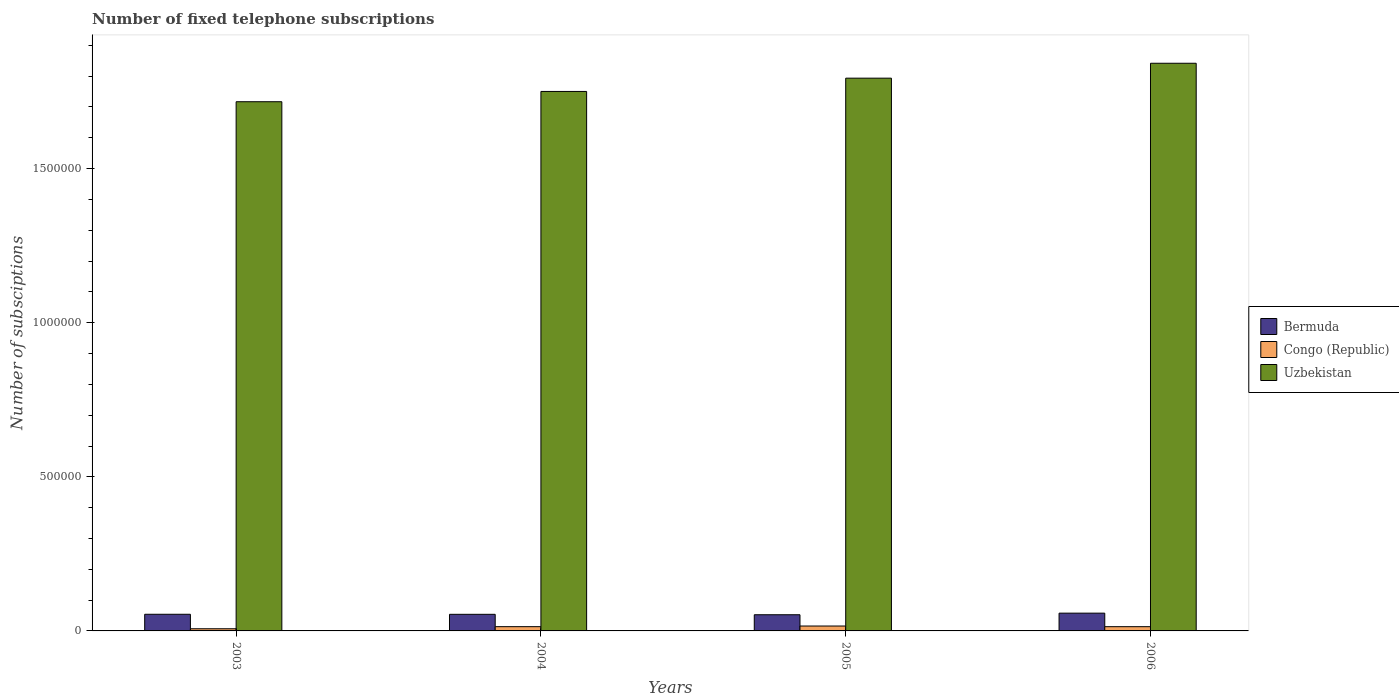How many groups of bars are there?
Provide a short and direct response. 4. Are the number of bars per tick equal to the number of legend labels?
Provide a short and direct response. Yes. Are the number of bars on each tick of the X-axis equal?
Offer a terse response. Yes. How many bars are there on the 1st tick from the left?
Give a very brief answer. 3. In how many cases, is the number of bars for a given year not equal to the number of legend labels?
Offer a very short reply. 0. What is the number of fixed telephone subscriptions in Bermuda in 2004?
Give a very brief answer. 5.38e+04. Across all years, what is the maximum number of fixed telephone subscriptions in Congo (Republic)?
Your answer should be very brief. 1.59e+04. Across all years, what is the minimum number of fixed telephone subscriptions in Uzbekistan?
Keep it short and to the point. 1.72e+06. In which year was the number of fixed telephone subscriptions in Uzbekistan minimum?
Make the answer very short. 2003. What is the total number of fixed telephone subscriptions in Bermuda in the graph?
Give a very brief answer. 2.18e+05. What is the difference between the number of fixed telephone subscriptions in Congo (Republic) in 2003 and that in 2004?
Provide a succinct answer. -6820. What is the difference between the number of fixed telephone subscriptions in Uzbekistan in 2005 and the number of fixed telephone subscriptions in Congo (Republic) in 2004?
Ensure brevity in your answer.  1.78e+06. What is the average number of fixed telephone subscriptions in Congo (Republic) per year?
Offer a terse response. 1.26e+04. In the year 2004, what is the difference between the number of fixed telephone subscriptions in Bermuda and number of fixed telephone subscriptions in Congo (Republic)?
Your answer should be very brief. 4.00e+04. What is the ratio of the number of fixed telephone subscriptions in Bermuda in 2003 to that in 2005?
Your response must be concise. 1.03. Is the difference between the number of fixed telephone subscriptions in Bermuda in 2003 and 2004 greater than the difference between the number of fixed telephone subscriptions in Congo (Republic) in 2003 and 2004?
Provide a succinct answer. Yes. What is the difference between the highest and the second highest number of fixed telephone subscriptions in Bermuda?
Provide a succinct answer. 3654. What is the difference between the highest and the lowest number of fixed telephone subscriptions in Uzbekistan?
Your answer should be compact. 1.25e+05. What does the 3rd bar from the left in 2006 represents?
Provide a succinct answer. Uzbekistan. What does the 3rd bar from the right in 2004 represents?
Give a very brief answer. Bermuda. Is it the case that in every year, the sum of the number of fixed telephone subscriptions in Congo (Republic) and number of fixed telephone subscriptions in Uzbekistan is greater than the number of fixed telephone subscriptions in Bermuda?
Your answer should be compact. Yes. Are all the bars in the graph horizontal?
Give a very brief answer. No. How many years are there in the graph?
Keep it short and to the point. 4. What is the difference between two consecutive major ticks on the Y-axis?
Your answer should be compact. 5.00e+05. Does the graph contain grids?
Ensure brevity in your answer.  No. Where does the legend appear in the graph?
Provide a short and direct response. Center right. How many legend labels are there?
Offer a terse response. 3. What is the title of the graph?
Offer a terse response. Number of fixed telephone subscriptions. What is the label or title of the X-axis?
Your answer should be very brief. Years. What is the label or title of the Y-axis?
Your answer should be very brief. Number of subsciptions. What is the Number of subsciptions of Bermuda in 2003?
Ensure brevity in your answer.  5.40e+04. What is the Number of subsciptions of Congo (Republic) in 2003?
Offer a terse response. 7000. What is the Number of subsciptions of Uzbekistan in 2003?
Offer a terse response. 1.72e+06. What is the Number of subsciptions of Bermuda in 2004?
Offer a very short reply. 5.38e+04. What is the Number of subsciptions of Congo (Republic) in 2004?
Offer a very short reply. 1.38e+04. What is the Number of subsciptions in Uzbekistan in 2004?
Make the answer very short. 1.75e+06. What is the Number of subsciptions of Bermuda in 2005?
Your answer should be very brief. 5.25e+04. What is the Number of subsciptions in Congo (Republic) in 2005?
Provide a succinct answer. 1.59e+04. What is the Number of subsciptions in Uzbekistan in 2005?
Provide a succinct answer. 1.79e+06. What is the Number of subsciptions in Bermuda in 2006?
Keep it short and to the point. 5.77e+04. What is the Number of subsciptions of Congo (Republic) in 2006?
Your answer should be very brief. 1.38e+04. What is the Number of subsciptions in Uzbekistan in 2006?
Provide a short and direct response. 1.84e+06. Across all years, what is the maximum Number of subsciptions of Bermuda?
Keep it short and to the point. 5.77e+04. Across all years, what is the maximum Number of subsciptions in Congo (Republic)?
Provide a succinct answer. 1.59e+04. Across all years, what is the maximum Number of subsciptions in Uzbekistan?
Make the answer very short. 1.84e+06. Across all years, what is the minimum Number of subsciptions of Bermuda?
Give a very brief answer. 5.25e+04. Across all years, what is the minimum Number of subsciptions of Congo (Republic)?
Keep it short and to the point. 7000. Across all years, what is the minimum Number of subsciptions in Uzbekistan?
Ensure brevity in your answer.  1.72e+06. What is the total Number of subsciptions of Bermuda in the graph?
Provide a short and direct response. 2.18e+05. What is the total Number of subsciptions in Congo (Republic) in the graph?
Provide a succinct answer. 5.05e+04. What is the total Number of subsciptions of Uzbekistan in the graph?
Give a very brief answer. 7.10e+06. What is the difference between the Number of subsciptions in Bermuda in 2003 and that in 2004?
Provide a succinct answer. 150. What is the difference between the Number of subsciptions in Congo (Republic) in 2003 and that in 2004?
Your answer should be very brief. -6820. What is the difference between the Number of subsciptions in Uzbekistan in 2003 and that in 2004?
Your response must be concise. -3.33e+04. What is the difference between the Number of subsciptions in Bermuda in 2003 and that in 2005?
Offer a terse response. 1529. What is the difference between the Number of subsciptions in Congo (Republic) in 2003 and that in 2005?
Offer a terse response. -8907. What is the difference between the Number of subsciptions of Uzbekistan in 2003 and that in 2005?
Provide a short and direct response. -7.64e+04. What is the difference between the Number of subsciptions in Bermuda in 2003 and that in 2006?
Offer a very short reply. -3654. What is the difference between the Number of subsciptions in Congo (Republic) in 2003 and that in 2006?
Keep it short and to the point. -6754. What is the difference between the Number of subsciptions of Uzbekistan in 2003 and that in 2006?
Offer a very short reply. -1.25e+05. What is the difference between the Number of subsciptions of Bermuda in 2004 and that in 2005?
Offer a very short reply. 1379. What is the difference between the Number of subsciptions in Congo (Republic) in 2004 and that in 2005?
Offer a terse response. -2087. What is the difference between the Number of subsciptions in Uzbekistan in 2004 and that in 2005?
Your answer should be very brief. -4.31e+04. What is the difference between the Number of subsciptions in Bermuda in 2004 and that in 2006?
Ensure brevity in your answer.  -3804. What is the difference between the Number of subsciptions of Congo (Republic) in 2004 and that in 2006?
Offer a very short reply. 66. What is the difference between the Number of subsciptions in Uzbekistan in 2004 and that in 2006?
Ensure brevity in your answer.  -9.15e+04. What is the difference between the Number of subsciptions in Bermuda in 2005 and that in 2006?
Offer a very short reply. -5183. What is the difference between the Number of subsciptions of Congo (Republic) in 2005 and that in 2006?
Make the answer very short. 2153. What is the difference between the Number of subsciptions of Uzbekistan in 2005 and that in 2006?
Keep it short and to the point. -4.84e+04. What is the difference between the Number of subsciptions of Bermuda in 2003 and the Number of subsciptions of Congo (Republic) in 2004?
Ensure brevity in your answer.  4.02e+04. What is the difference between the Number of subsciptions in Bermuda in 2003 and the Number of subsciptions in Uzbekistan in 2004?
Offer a very short reply. -1.70e+06. What is the difference between the Number of subsciptions in Congo (Republic) in 2003 and the Number of subsciptions in Uzbekistan in 2004?
Offer a very short reply. -1.74e+06. What is the difference between the Number of subsciptions in Bermuda in 2003 and the Number of subsciptions in Congo (Republic) in 2005?
Provide a short and direct response. 3.81e+04. What is the difference between the Number of subsciptions of Bermuda in 2003 and the Number of subsciptions of Uzbekistan in 2005?
Provide a succinct answer. -1.74e+06. What is the difference between the Number of subsciptions of Congo (Republic) in 2003 and the Number of subsciptions of Uzbekistan in 2005?
Give a very brief answer. -1.79e+06. What is the difference between the Number of subsciptions in Bermuda in 2003 and the Number of subsciptions in Congo (Republic) in 2006?
Your answer should be very brief. 4.02e+04. What is the difference between the Number of subsciptions of Bermuda in 2003 and the Number of subsciptions of Uzbekistan in 2006?
Your answer should be compact. -1.79e+06. What is the difference between the Number of subsciptions of Congo (Republic) in 2003 and the Number of subsciptions of Uzbekistan in 2006?
Make the answer very short. -1.83e+06. What is the difference between the Number of subsciptions in Bermuda in 2004 and the Number of subsciptions in Congo (Republic) in 2005?
Provide a short and direct response. 3.79e+04. What is the difference between the Number of subsciptions in Bermuda in 2004 and the Number of subsciptions in Uzbekistan in 2005?
Keep it short and to the point. -1.74e+06. What is the difference between the Number of subsciptions of Congo (Republic) in 2004 and the Number of subsciptions of Uzbekistan in 2005?
Make the answer very short. -1.78e+06. What is the difference between the Number of subsciptions in Bermuda in 2004 and the Number of subsciptions in Congo (Republic) in 2006?
Offer a very short reply. 4.01e+04. What is the difference between the Number of subsciptions in Bermuda in 2004 and the Number of subsciptions in Uzbekistan in 2006?
Your answer should be compact. -1.79e+06. What is the difference between the Number of subsciptions of Congo (Republic) in 2004 and the Number of subsciptions of Uzbekistan in 2006?
Provide a succinct answer. -1.83e+06. What is the difference between the Number of subsciptions of Bermuda in 2005 and the Number of subsciptions of Congo (Republic) in 2006?
Offer a very short reply. 3.87e+04. What is the difference between the Number of subsciptions in Bermuda in 2005 and the Number of subsciptions in Uzbekistan in 2006?
Ensure brevity in your answer.  -1.79e+06. What is the difference between the Number of subsciptions of Congo (Republic) in 2005 and the Number of subsciptions of Uzbekistan in 2006?
Offer a terse response. -1.83e+06. What is the average Number of subsciptions in Bermuda per year?
Your response must be concise. 5.45e+04. What is the average Number of subsciptions of Congo (Republic) per year?
Your answer should be very brief. 1.26e+04. What is the average Number of subsciptions in Uzbekistan per year?
Offer a terse response. 1.78e+06. In the year 2003, what is the difference between the Number of subsciptions of Bermuda and Number of subsciptions of Congo (Republic)?
Give a very brief answer. 4.70e+04. In the year 2003, what is the difference between the Number of subsciptions of Bermuda and Number of subsciptions of Uzbekistan?
Give a very brief answer. -1.66e+06. In the year 2003, what is the difference between the Number of subsciptions in Congo (Republic) and Number of subsciptions in Uzbekistan?
Offer a terse response. -1.71e+06. In the year 2004, what is the difference between the Number of subsciptions in Bermuda and Number of subsciptions in Congo (Republic)?
Offer a very short reply. 4.00e+04. In the year 2004, what is the difference between the Number of subsciptions in Bermuda and Number of subsciptions in Uzbekistan?
Your answer should be compact. -1.70e+06. In the year 2004, what is the difference between the Number of subsciptions of Congo (Republic) and Number of subsciptions of Uzbekistan?
Provide a short and direct response. -1.74e+06. In the year 2005, what is the difference between the Number of subsciptions of Bermuda and Number of subsciptions of Congo (Republic)?
Provide a short and direct response. 3.66e+04. In the year 2005, what is the difference between the Number of subsciptions of Bermuda and Number of subsciptions of Uzbekistan?
Ensure brevity in your answer.  -1.74e+06. In the year 2005, what is the difference between the Number of subsciptions in Congo (Republic) and Number of subsciptions in Uzbekistan?
Provide a succinct answer. -1.78e+06. In the year 2006, what is the difference between the Number of subsciptions in Bermuda and Number of subsciptions in Congo (Republic)?
Offer a terse response. 4.39e+04. In the year 2006, what is the difference between the Number of subsciptions of Bermuda and Number of subsciptions of Uzbekistan?
Provide a succinct answer. -1.78e+06. In the year 2006, what is the difference between the Number of subsciptions of Congo (Republic) and Number of subsciptions of Uzbekistan?
Provide a short and direct response. -1.83e+06. What is the ratio of the Number of subsciptions in Bermuda in 2003 to that in 2004?
Provide a succinct answer. 1. What is the ratio of the Number of subsciptions of Congo (Republic) in 2003 to that in 2004?
Keep it short and to the point. 0.51. What is the ratio of the Number of subsciptions of Bermuda in 2003 to that in 2005?
Give a very brief answer. 1.03. What is the ratio of the Number of subsciptions in Congo (Republic) in 2003 to that in 2005?
Your response must be concise. 0.44. What is the ratio of the Number of subsciptions of Uzbekistan in 2003 to that in 2005?
Provide a short and direct response. 0.96. What is the ratio of the Number of subsciptions of Bermuda in 2003 to that in 2006?
Provide a short and direct response. 0.94. What is the ratio of the Number of subsciptions in Congo (Republic) in 2003 to that in 2006?
Offer a very short reply. 0.51. What is the ratio of the Number of subsciptions of Uzbekistan in 2003 to that in 2006?
Provide a succinct answer. 0.93. What is the ratio of the Number of subsciptions of Bermuda in 2004 to that in 2005?
Offer a very short reply. 1.03. What is the ratio of the Number of subsciptions of Congo (Republic) in 2004 to that in 2005?
Ensure brevity in your answer.  0.87. What is the ratio of the Number of subsciptions in Bermuda in 2004 to that in 2006?
Make the answer very short. 0.93. What is the ratio of the Number of subsciptions in Congo (Republic) in 2004 to that in 2006?
Your answer should be compact. 1. What is the ratio of the Number of subsciptions in Uzbekistan in 2004 to that in 2006?
Give a very brief answer. 0.95. What is the ratio of the Number of subsciptions of Bermuda in 2005 to that in 2006?
Give a very brief answer. 0.91. What is the ratio of the Number of subsciptions of Congo (Republic) in 2005 to that in 2006?
Your answer should be very brief. 1.16. What is the ratio of the Number of subsciptions in Uzbekistan in 2005 to that in 2006?
Provide a succinct answer. 0.97. What is the difference between the highest and the second highest Number of subsciptions of Bermuda?
Your answer should be compact. 3654. What is the difference between the highest and the second highest Number of subsciptions in Congo (Republic)?
Offer a terse response. 2087. What is the difference between the highest and the second highest Number of subsciptions of Uzbekistan?
Give a very brief answer. 4.84e+04. What is the difference between the highest and the lowest Number of subsciptions in Bermuda?
Provide a succinct answer. 5183. What is the difference between the highest and the lowest Number of subsciptions in Congo (Republic)?
Give a very brief answer. 8907. What is the difference between the highest and the lowest Number of subsciptions of Uzbekistan?
Provide a succinct answer. 1.25e+05. 